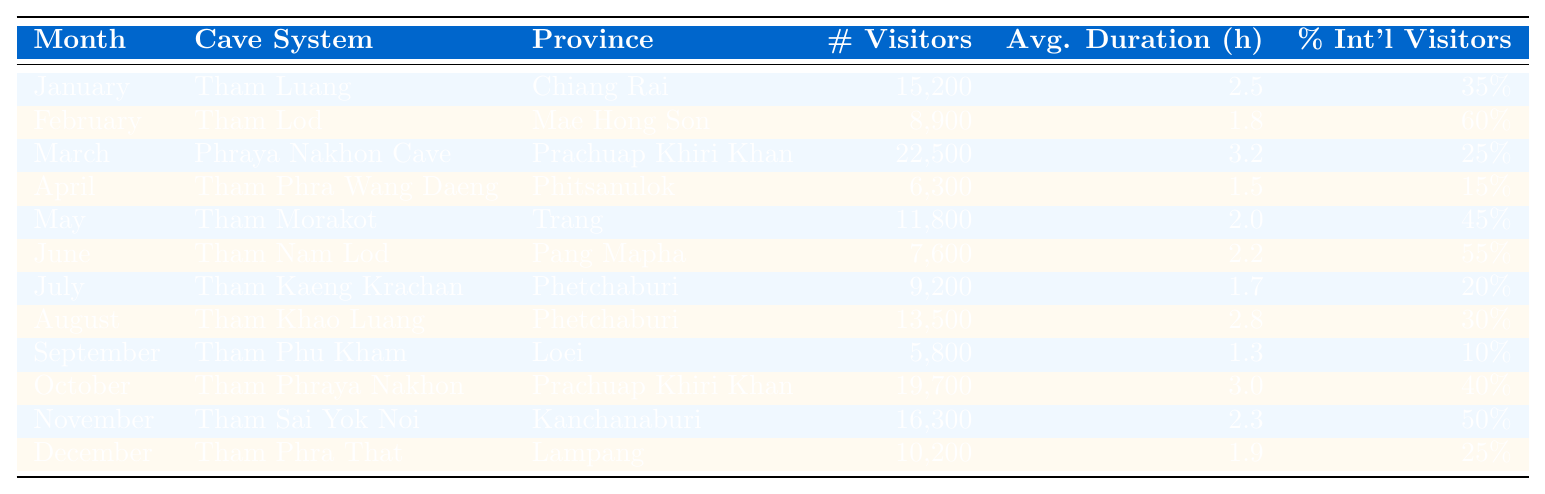What is the cave system with the highest number of visitors in March? In March, the table shows that the Phraya Nakhon Cave in Prachuap Khiri Khan had 22,500 visitors, which is the highest number of visitors for that month.
Answer: Phraya Nakhon Cave How many international visitors were there in February? In February, the table indicates that Tham Lod in Mae Hong Son had 60% international visitors out of a total of 8,900 visitors. Therefore, the number of international visitors is 60% of 8,900, which is 0.6 * 8900 = 5,340.
Answer: 5,340 What was the average visit duration across all cave systems in July? To find the average visit duration in July, we see from the table that Tham Kaeng Krachan had an average visit duration of 1.7 hours. Since this is the only data for July, the average duration is simply 1.7 hours.
Answer: 1.7 hours Which month had the lowest number of visitors? From the table, we can see that September had the lowest number of visitors with 5,800 visitors recorded at Tham Phu Kham in Loei.
Answer: September What was the total number of visitors for the cave systems in the month of October and November combined? For October, Tham Phraya Nakhon saw 19,700 visitors and for November, Tham Sai Yok Noi had 16,300 visitors. Adding these amounts gives a combined total of 19,700 + 16,300 = 36,000 visitors for these two months.
Answer: 36,000 How does the average duration of visits in the cave systems compare between January and December? In January, the average duration is 2.5 hours, while in December the average duration is 1.9 hours. To compare, we determine that 2.5 hours is greater than 1.9 hours, which shows that visitors in January spent more time compared to December.
Answer: January had a longer duration Is the percentage of international visitors higher in April or July? In April, the table shows that 15% of visitors were international, while in July, the percentage was 20%. Since 20% is greater than 15%, the percentage of international visitors is higher in July compared to April.
Answer: July What are the average visitors for cave systems located in Phetchaburi? From the table, Tham Kaeng Krachan and Tham Khao Luang in Phetchaburi had 9,200 and 13,500 visitors respectively. To find the average, we add these two numbers (9,200 + 13,500 = 22,700) and divide by 2, yielding an average of 22,700 / 2 = 11,350.
Answer: 11,350 Which cave system had the highest percentage of international visitors? Looking at the percentages in the table, Tham Lod in February has the highest percentage at 60%, making it the cave system with the highest percentage of international visitors.
Answer: Tham Lod 